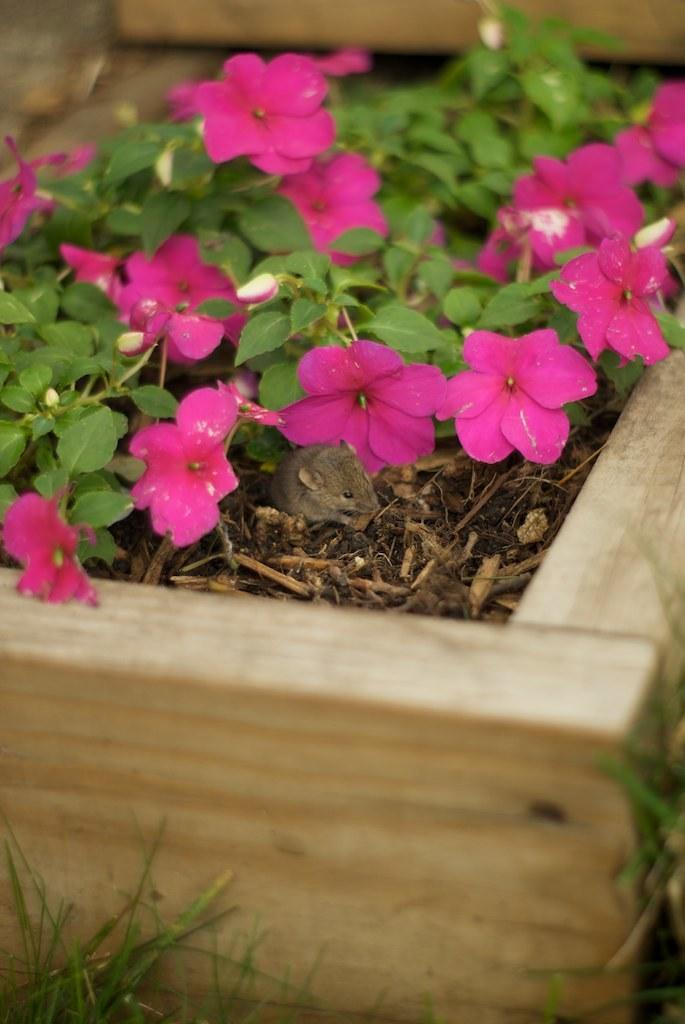What type of plants can be seen in the image? There are flowers, leaves, and twigs in the image. What is the natural environment visible in the image? There is grass at the bottom of the image. What material is the wooden object made of? The wooden object at the bottom of the image is made of wood. What other objects can be seen in the image besides plants and the wooden object? There are other objects in the image, but their specific details are not mentioned in the provided facts. What color is the crayon used to draw the shoe in the image? There is no crayon or shoe present in the image. What is the cause of the flowers wilting in the image? There is no indication in the image that the flowers are wilting, and therefore no cause can be determined. 